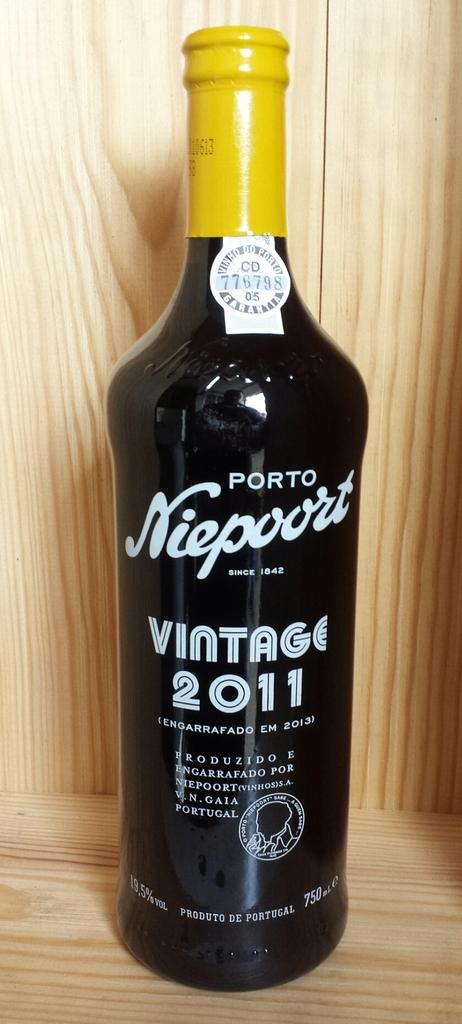Provide a one-sentence caption for the provided image. Porto Niesport wine bottle with yellow top on a wooden surface. 